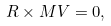Convert formula to latex. <formula><loc_0><loc_0><loc_500><loc_500>R \times M V = 0 ,</formula> 